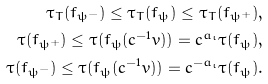<formula> <loc_0><loc_0><loc_500><loc_500>\tau _ { T } ( f _ { \psi ^ { - } } ) \leq \tau _ { T } ( f _ { \psi } ) \leq \tau _ { T } ( f _ { \psi ^ { + } } ) , \\ \tau ( f _ { \psi ^ { + } } ) \leq \tau ( f _ { \psi } ( c ^ { - 1 } v ) ) = c ^ { a _ { \iota } } \tau ( f _ { \psi } ) , \\ \tau ( f _ { \psi ^ { - } } ) \leq \tau ( f _ { \psi } ( c ^ { - 1 } v ) ) = c ^ { - a _ { \iota } } \tau ( f _ { \psi } ) .</formula> 